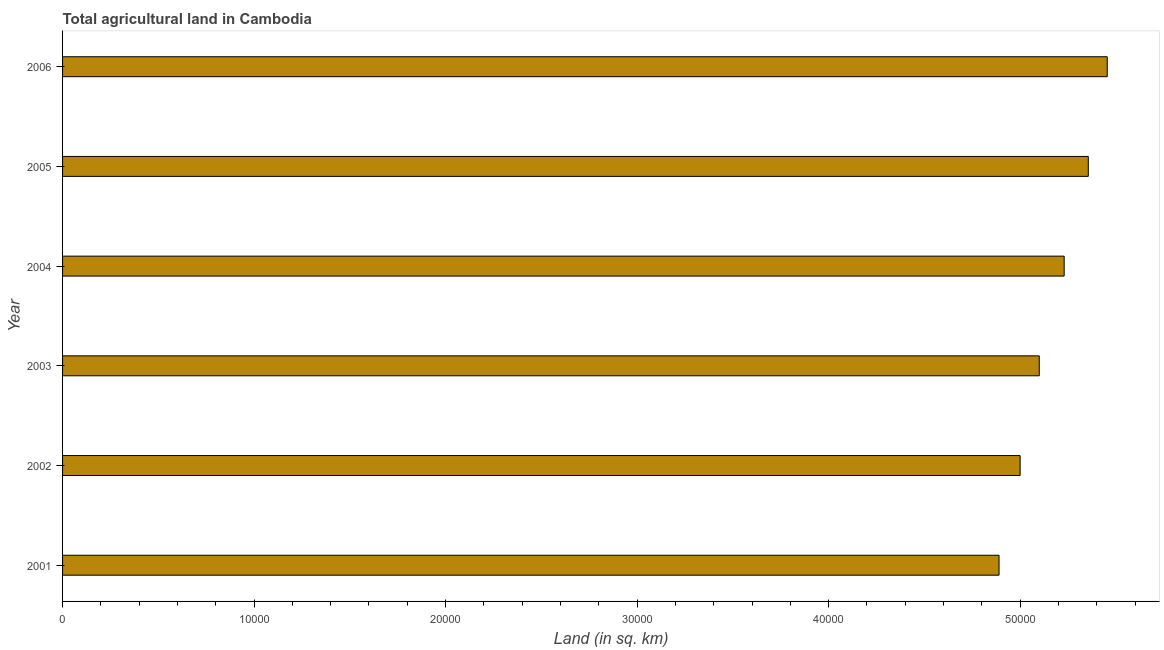Does the graph contain any zero values?
Ensure brevity in your answer.  No. What is the title of the graph?
Offer a very short reply. Total agricultural land in Cambodia. What is the label or title of the X-axis?
Provide a succinct answer. Land (in sq. km). What is the agricultural land in 2005?
Ensure brevity in your answer.  5.36e+04. Across all years, what is the maximum agricultural land?
Offer a very short reply. 5.46e+04. Across all years, what is the minimum agricultural land?
Provide a short and direct response. 4.89e+04. In which year was the agricultural land maximum?
Keep it short and to the point. 2006. In which year was the agricultural land minimum?
Ensure brevity in your answer.  2001. What is the sum of the agricultural land?
Ensure brevity in your answer.  3.10e+05. What is the difference between the agricultural land in 2003 and 2004?
Offer a very short reply. -1300. What is the average agricultural land per year?
Your answer should be compact. 5.17e+04. What is the median agricultural land?
Your answer should be very brief. 5.16e+04. Do a majority of the years between 2001 and 2004 (inclusive) have agricultural land greater than 30000 sq. km?
Give a very brief answer. Yes. What is the ratio of the agricultural land in 2004 to that in 2005?
Keep it short and to the point. 0.98. Is the difference between the agricultural land in 2003 and 2005 greater than the difference between any two years?
Your answer should be compact. No. What is the difference between the highest and the second highest agricultural land?
Provide a succinct answer. 990. What is the difference between the highest and the lowest agricultural land?
Your answer should be compact. 5650. Are all the bars in the graph horizontal?
Offer a terse response. Yes. How many years are there in the graph?
Your response must be concise. 6. What is the difference between two consecutive major ticks on the X-axis?
Your answer should be compact. 10000. Are the values on the major ticks of X-axis written in scientific E-notation?
Keep it short and to the point. No. What is the Land (in sq. km) of 2001?
Provide a succinct answer. 4.89e+04. What is the Land (in sq. km) in 2003?
Offer a terse response. 5.10e+04. What is the Land (in sq. km) of 2004?
Provide a short and direct response. 5.23e+04. What is the Land (in sq. km) in 2005?
Provide a succinct answer. 5.36e+04. What is the Land (in sq. km) of 2006?
Give a very brief answer. 5.46e+04. What is the difference between the Land (in sq. km) in 2001 and 2002?
Make the answer very short. -1100. What is the difference between the Land (in sq. km) in 2001 and 2003?
Give a very brief answer. -2100. What is the difference between the Land (in sq. km) in 2001 and 2004?
Provide a succinct answer. -3400. What is the difference between the Land (in sq. km) in 2001 and 2005?
Your answer should be compact. -4660. What is the difference between the Land (in sq. km) in 2001 and 2006?
Offer a very short reply. -5650. What is the difference between the Land (in sq. km) in 2002 and 2003?
Keep it short and to the point. -1000. What is the difference between the Land (in sq. km) in 2002 and 2004?
Make the answer very short. -2300. What is the difference between the Land (in sq. km) in 2002 and 2005?
Offer a very short reply. -3560. What is the difference between the Land (in sq. km) in 2002 and 2006?
Provide a succinct answer. -4550. What is the difference between the Land (in sq. km) in 2003 and 2004?
Ensure brevity in your answer.  -1300. What is the difference between the Land (in sq. km) in 2003 and 2005?
Your response must be concise. -2560. What is the difference between the Land (in sq. km) in 2003 and 2006?
Give a very brief answer. -3550. What is the difference between the Land (in sq. km) in 2004 and 2005?
Provide a short and direct response. -1260. What is the difference between the Land (in sq. km) in 2004 and 2006?
Give a very brief answer. -2250. What is the difference between the Land (in sq. km) in 2005 and 2006?
Your response must be concise. -990. What is the ratio of the Land (in sq. km) in 2001 to that in 2002?
Provide a succinct answer. 0.98. What is the ratio of the Land (in sq. km) in 2001 to that in 2004?
Provide a short and direct response. 0.94. What is the ratio of the Land (in sq. km) in 2001 to that in 2006?
Keep it short and to the point. 0.9. What is the ratio of the Land (in sq. km) in 2002 to that in 2003?
Make the answer very short. 0.98. What is the ratio of the Land (in sq. km) in 2002 to that in 2004?
Give a very brief answer. 0.96. What is the ratio of the Land (in sq. km) in 2002 to that in 2005?
Your answer should be very brief. 0.93. What is the ratio of the Land (in sq. km) in 2002 to that in 2006?
Ensure brevity in your answer.  0.92. What is the ratio of the Land (in sq. km) in 2003 to that in 2005?
Your answer should be very brief. 0.95. What is the ratio of the Land (in sq. km) in 2003 to that in 2006?
Your response must be concise. 0.94. What is the ratio of the Land (in sq. km) in 2004 to that in 2005?
Keep it short and to the point. 0.98. What is the ratio of the Land (in sq. km) in 2004 to that in 2006?
Your answer should be compact. 0.96. 